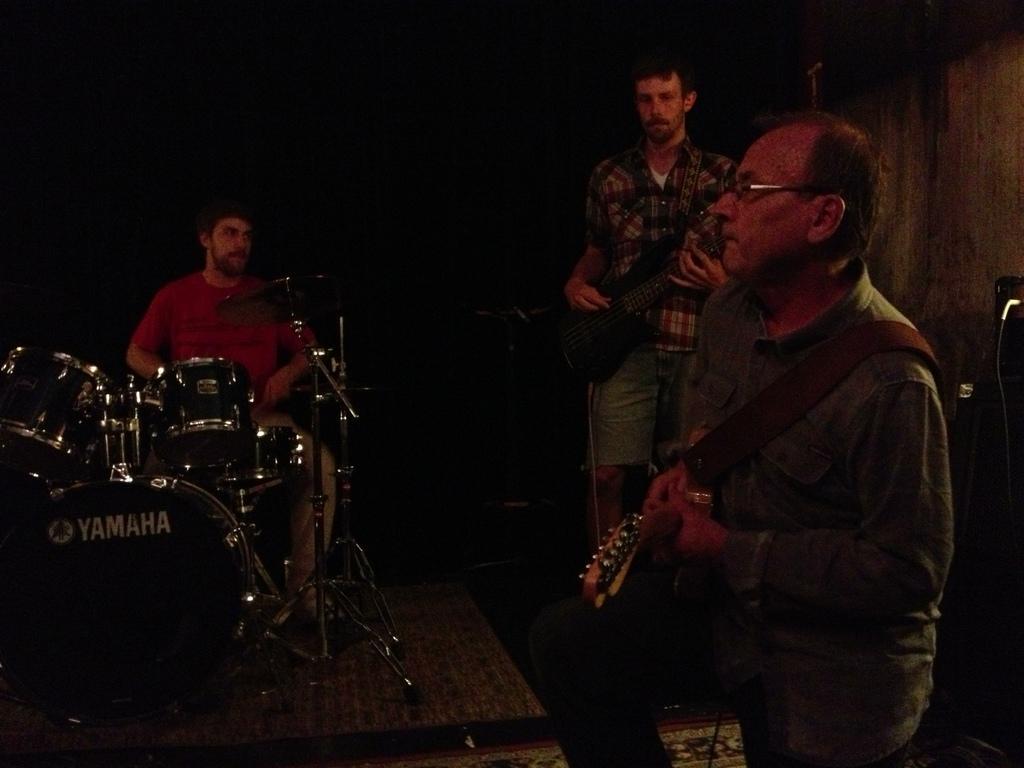How would you summarize this image in a sentence or two? In this image I can see few men were two of them are holding musical instruments and a man is sitting next to a drum set. 